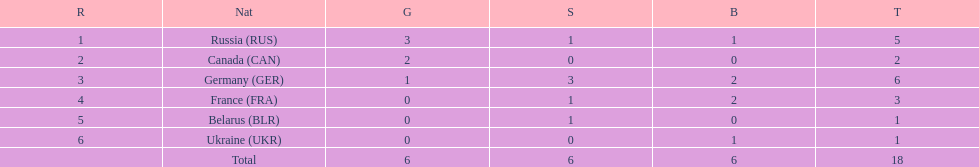What country only received gold medals in the 1994 winter olympics biathlon? Canada (CAN). 